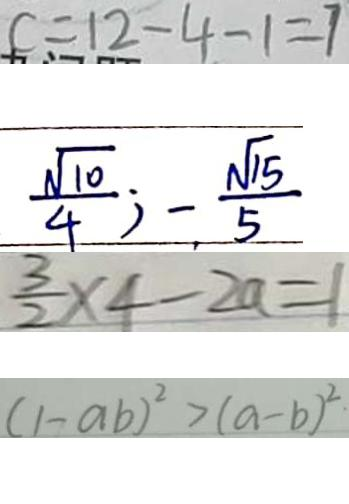<formula> <loc_0><loc_0><loc_500><loc_500>c = 1 2 - 4 - 1 = 7 
 \frac { \sqrt { 1 0 } } { 4 } ; - \frac { \sqrt { 1 5 } } { 5 } 
 \frac { 3 } { 2 } \times 4 - 2 a = 1 
 ( 1 - a b ) ^ { 2 } > ( a - b ) ^ { 2 }</formula> 